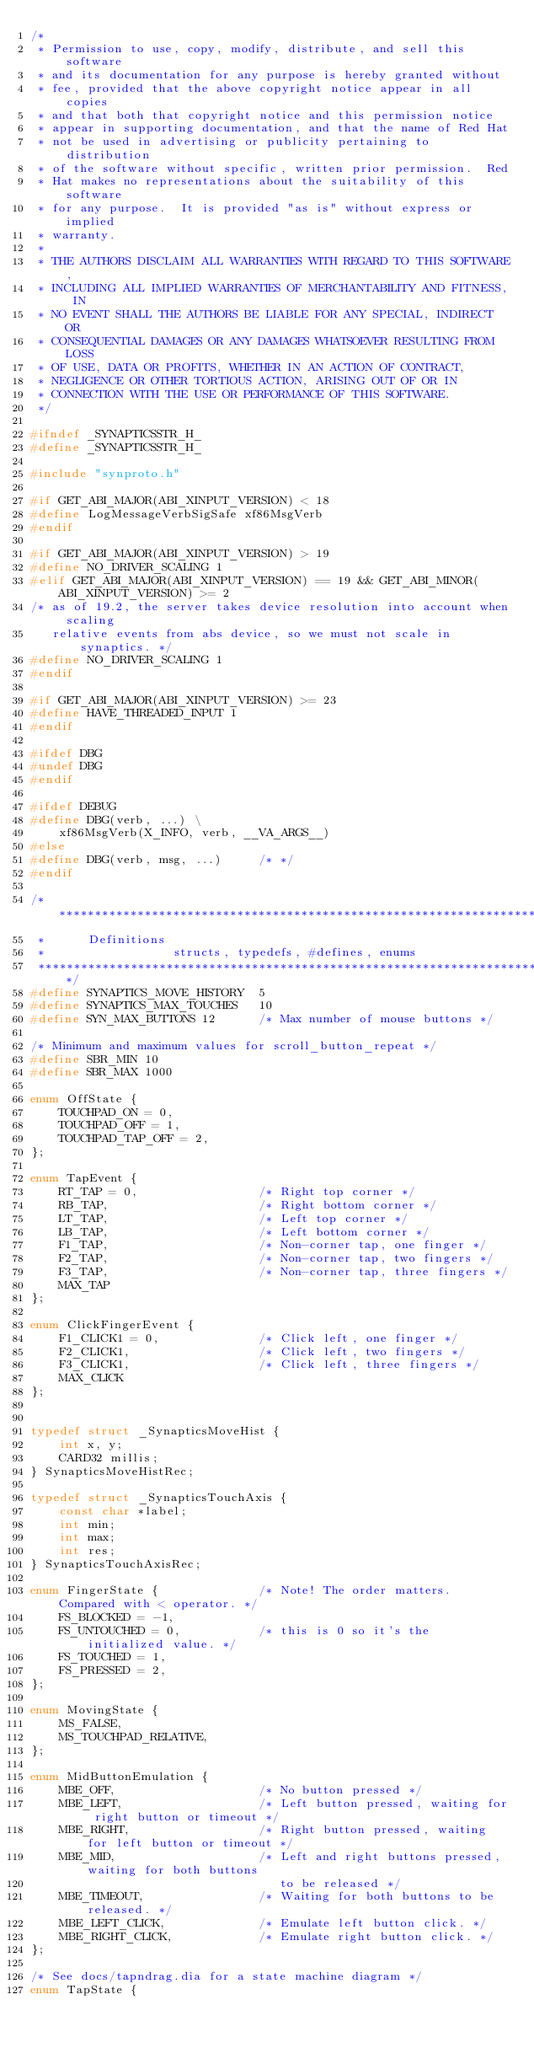Convert code to text. <code><loc_0><loc_0><loc_500><loc_500><_C_>/*
 * Permission to use, copy, modify, distribute, and sell this software
 * and its documentation for any purpose is hereby granted without
 * fee, provided that the above copyright notice appear in all copies
 * and that both that copyright notice and this permission notice
 * appear in supporting documentation, and that the name of Red Hat
 * not be used in advertising or publicity pertaining to distribution
 * of the software without specific, written prior permission.  Red
 * Hat makes no representations about the suitability of this software
 * for any purpose.  It is provided "as is" without express or implied
 * warranty.
 *
 * THE AUTHORS DISCLAIM ALL WARRANTIES WITH REGARD TO THIS SOFTWARE,
 * INCLUDING ALL IMPLIED WARRANTIES OF MERCHANTABILITY AND FITNESS, IN
 * NO EVENT SHALL THE AUTHORS BE LIABLE FOR ANY SPECIAL, INDIRECT OR
 * CONSEQUENTIAL DAMAGES OR ANY DAMAGES WHATSOEVER RESULTING FROM LOSS
 * OF USE, DATA OR PROFITS, WHETHER IN AN ACTION OF CONTRACT,
 * NEGLIGENCE OR OTHER TORTIOUS ACTION, ARISING OUT OF OR IN
 * CONNECTION WITH THE USE OR PERFORMANCE OF THIS SOFTWARE.
 */

#ifndef	_SYNAPTICSSTR_H_
#define _SYNAPTICSSTR_H_

#include "synproto.h"

#if GET_ABI_MAJOR(ABI_XINPUT_VERSION) < 18
#define LogMessageVerbSigSafe xf86MsgVerb
#endif

#if GET_ABI_MAJOR(ABI_XINPUT_VERSION) > 19
#define NO_DRIVER_SCALING 1
#elif GET_ABI_MAJOR(ABI_XINPUT_VERSION) == 19 && GET_ABI_MINOR(ABI_XINPUT_VERSION) >= 2
/* as of 19.2, the server takes device resolution into account when scaling
   relative events from abs device, so we must not scale in synaptics. */
#define NO_DRIVER_SCALING 1
#endif

#if GET_ABI_MAJOR(ABI_XINPUT_VERSION) >= 23
#define HAVE_THREADED_INPUT 1
#endif

#ifdef DBG
#undef DBG
#endif

#ifdef DEBUG
#define DBG(verb, ...) \
    xf86MsgVerb(X_INFO, verb, __VA_ARGS__)
#else
#define DBG(verb, msg, ...)     /* */
#endif

/******************************************************************************
 *		Definitions
 *					structs, typedefs, #defines, enums
 *****************************************************************************/
#define SYNAPTICS_MOVE_HISTORY	5
#define SYNAPTICS_MAX_TOUCHES	10
#define SYN_MAX_BUTTONS 12      /* Max number of mouse buttons */

/* Minimum and maximum values for scroll_button_repeat */
#define SBR_MIN 10
#define SBR_MAX 1000

enum OffState {
    TOUCHPAD_ON = 0,
    TOUCHPAD_OFF = 1,
    TOUCHPAD_TAP_OFF = 2,
};

enum TapEvent {
    RT_TAP = 0,                 /* Right top corner */
    RB_TAP,                     /* Right bottom corner */
    LT_TAP,                     /* Left top corner */
    LB_TAP,                     /* Left bottom corner */
    F1_TAP,                     /* Non-corner tap, one finger */
    F2_TAP,                     /* Non-corner tap, two fingers */
    F3_TAP,                     /* Non-corner tap, three fingers */
    MAX_TAP
};

enum ClickFingerEvent {
    F1_CLICK1 = 0,              /* Click left, one finger */
    F2_CLICK1,                  /* Click left, two fingers */
    F3_CLICK1,                  /* Click left, three fingers */
    MAX_CLICK
};


typedef struct _SynapticsMoveHist {
    int x, y;
    CARD32 millis;
} SynapticsMoveHistRec;

typedef struct _SynapticsTouchAxis {
    const char *label;
    int min;
    int max;
    int res;
} SynapticsTouchAxisRec;

enum FingerState {              /* Note! The order matters. Compared with < operator. */
    FS_BLOCKED = -1,
    FS_UNTOUCHED = 0,           /* this is 0 so it's the initialized value. */
    FS_TOUCHED = 1,
    FS_PRESSED = 2,
};

enum MovingState {
    MS_FALSE,
    MS_TOUCHPAD_RELATIVE,
};

enum MidButtonEmulation {
    MBE_OFF,                    /* No button pressed */
    MBE_LEFT,                   /* Left button pressed, waiting for right button or timeout */
    MBE_RIGHT,                  /* Right button pressed, waiting for left button or timeout */
    MBE_MID,                    /* Left and right buttons pressed, waiting for both buttons
                                   to be released */
    MBE_TIMEOUT,                /* Waiting for both buttons to be released. */
    MBE_LEFT_CLICK,             /* Emulate left button click. */
    MBE_RIGHT_CLICK,            /* Emulate right button click. */
};

/* See docs/tapndrag.dia for a state machine diagram */
enum TapState {</code> 